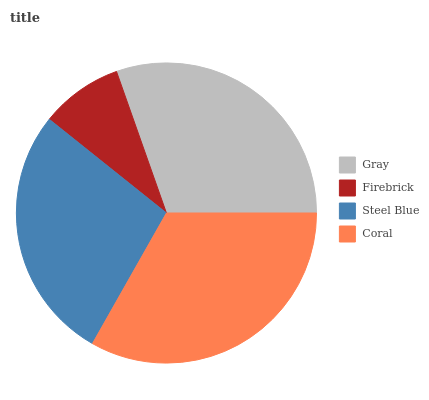Is Firebrick the minimum?
Answer yes or no. Yes. Is Coral the maximum?
Answer yes or no. Yes. Is Steel Blue the minimum?
Answer yes or no. No. Is Steel Blue the maximum?
Answer yes or no. No. Is Steel Blue greater than Firebrick?
Answer yes or no. Yes. Is Firebrick less than Steel Blue?
Answer yes or no. Yes. Is Firebrick greater than Steel Blue?
Answer yes or no. No. Is Steel Blue less than Firebrick?
Answer yes or no. No. Is Gray the high median?
Answer yes or no. Yes. Is Steel Blue the low median?
Answer yes or no. Yes. Is Steel Blue the high median?
Answer yes or no. No. Is Coral the low median?
Answer yes or no. No. 